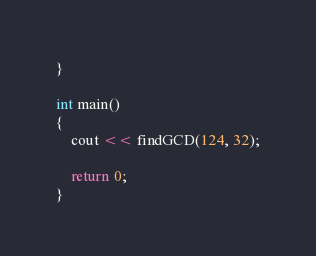<code> <loc_0><loc_0><loc_500><loc_500><_C++_>}

int main()
{
    cout << findGCD(124, 32);

    return 0;
}</code> 